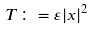<formula> <loc_0><loc_0><loc_500><loc_500>T \colon = \varepsilon | x | ^ { 2 }</formula> 